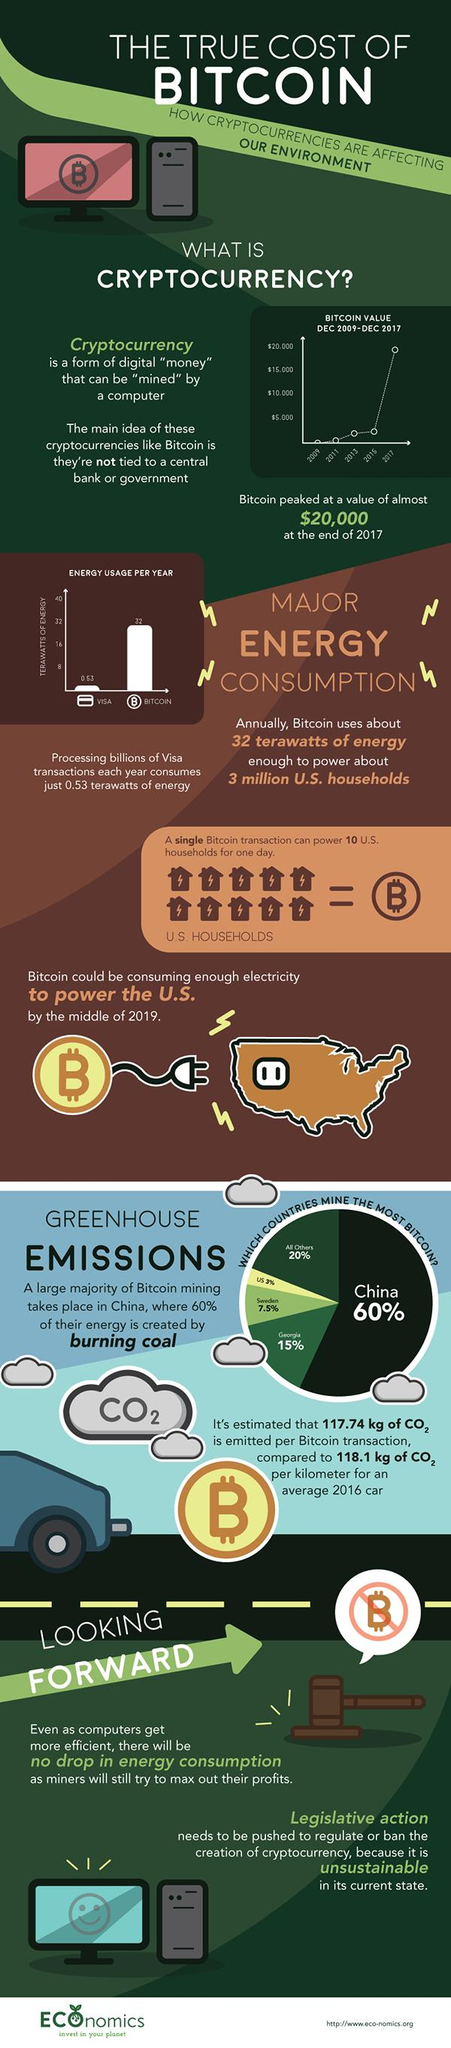Draw attention to some important aspects in this diagram. The value of bitcoin was lowest in 2009. The Visa form of transaction consumes less energy than the other form of transaction. According to recent data, the country of Georgia is the largest miner of bitcoins after China. 